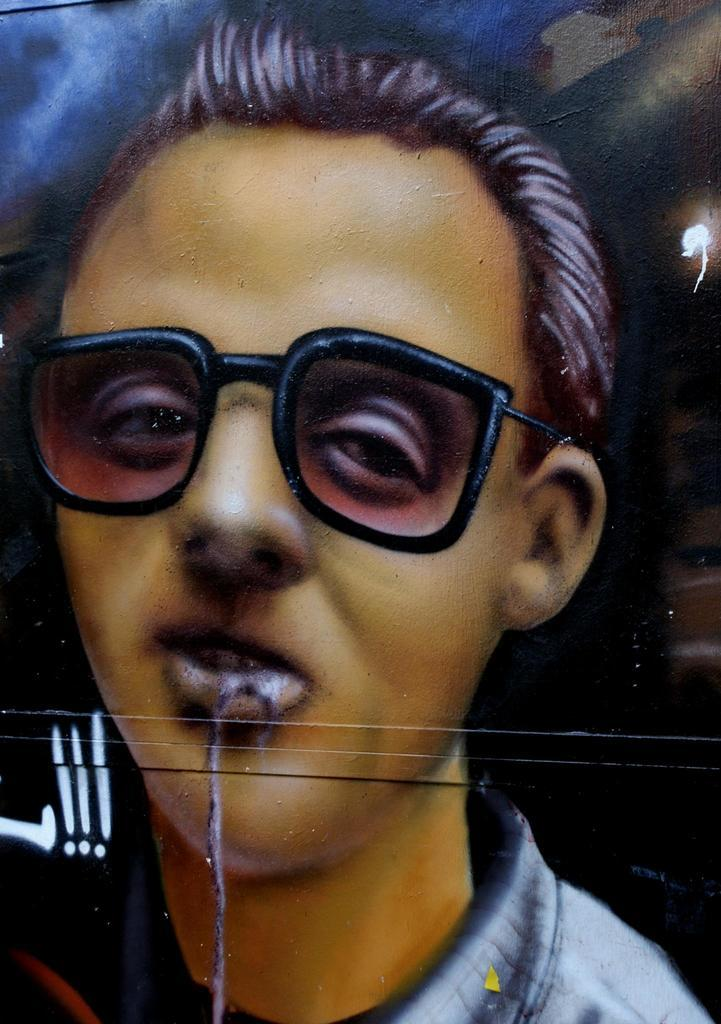Who is present in the image? There is a man in the image. What is the man wearing on his face? The man is wearing shades. Can you describe the background of the image? The background of the image includes blue and black colors. What type of advice can be seen written on the snakes in the image? There are no snakes present in the image, so no advice can be seen written on them. 